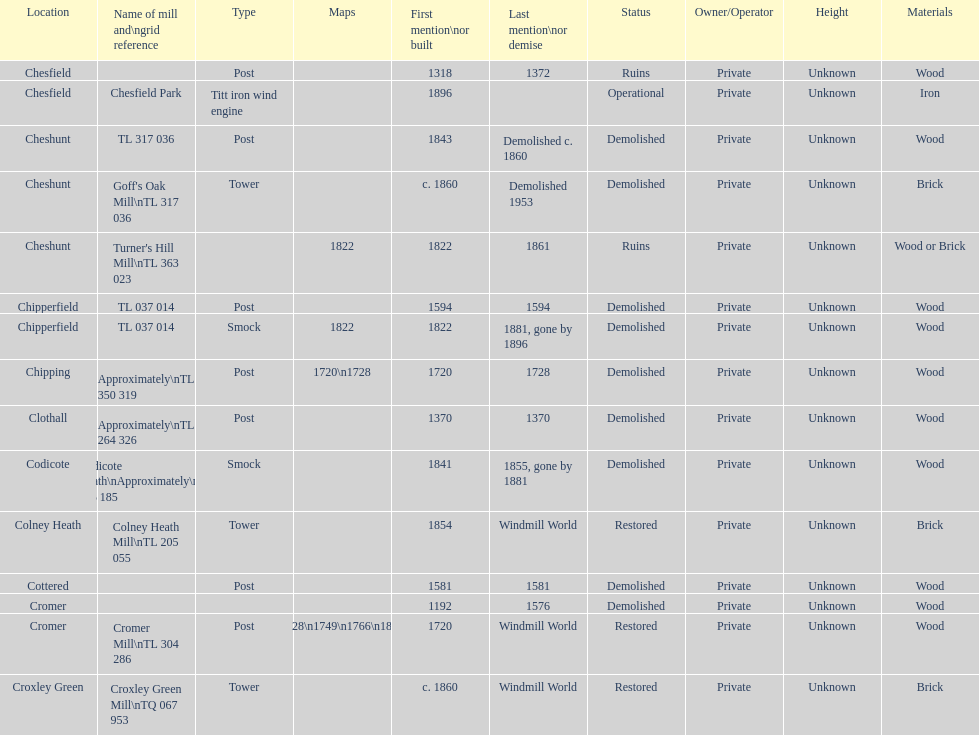How many mills were mentioned or built before 1700? 5. 